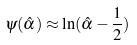Convert formula to latex. <formula><loc_0><loc_0><loc_500><loc_500>\psi ( \hat { \alpha } ) \approx \ln ( \hat { \alpha } - \frac { 1 } { 2 } )</formula> 